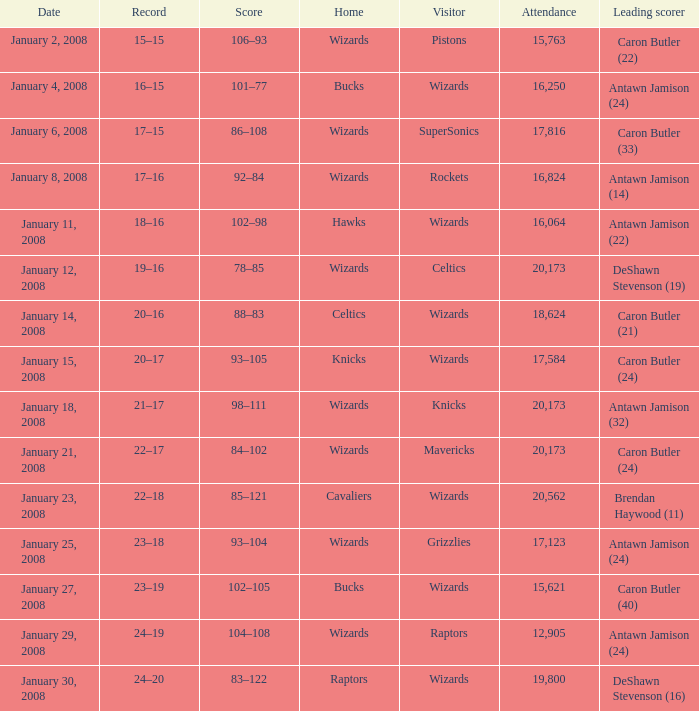What is the record when the leading scorer is Antawn Jamison (14)? 17–16. 